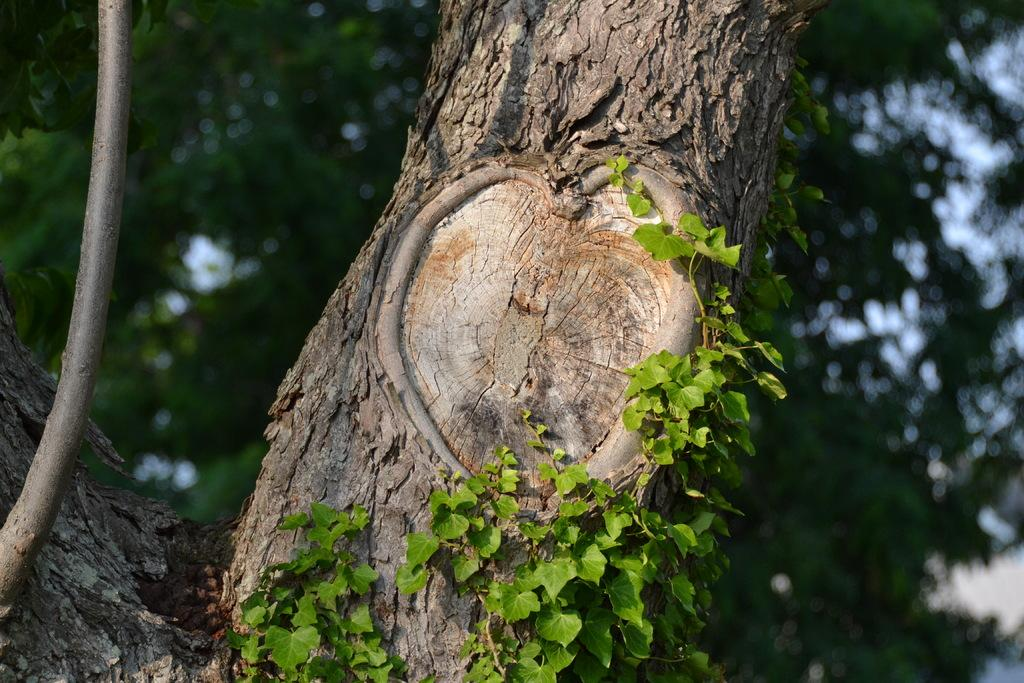What is the main subject of the image? The main subject of the image is a tree trunk with leaves. What can be seen in the background of the image? There are trees and the sky visible in the background of the image. How would you describe the appearance of the background? The background appears blurry. How many fingers can be seen on the tree trunk in the image? There are no fingers present on the tree trunk in the image. What type of stomach is visible on the tree trunk in the image? There is no stomach present on the tree trunk in the image. 